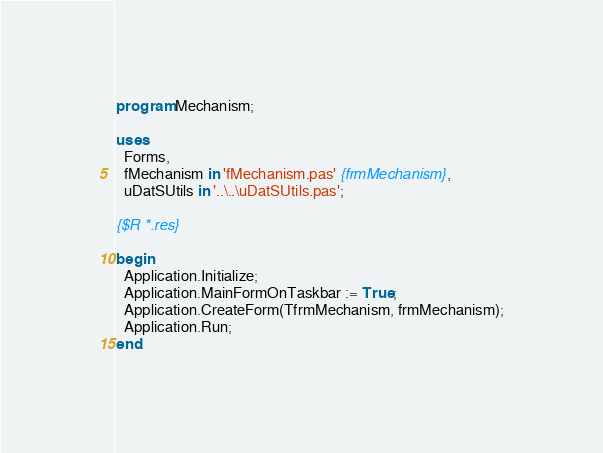Convert code to text. <code><loc_0><loc_0><loc_500><loc_500><_Pascal_>program Mechanism;

uses
  Forms,
  fMechanism in 'fMechanism.pas' {frmMechanism},
  uDatSUtils in '..\..\uDatSUtils.pas';

{$R *.res}

begin
  Application.Initialize;
  Application.MainFormOnTaskbar := True;
  Application.CreateForm(TfrmMechanism, frmMechanism);
  Application.Run;
end.
</code> 